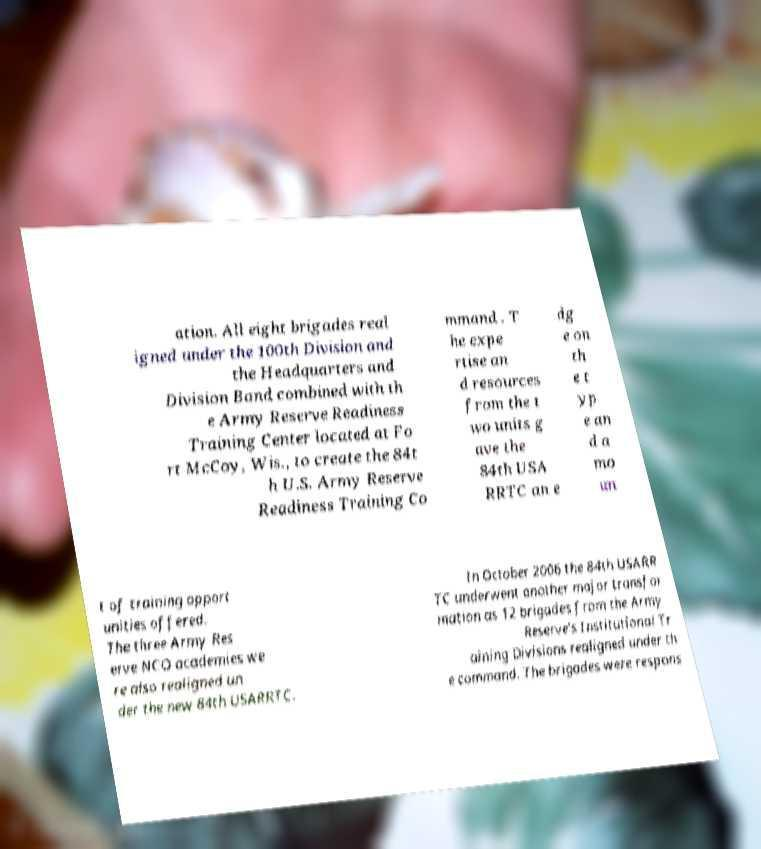Can you read and provide the text displayed in the image?This photo seems to have some interesting text. Can you extract and type it out for me? ation. All eight brigades real igned under the 100th Division and the Headquarters and Division Band combined with th e Army Reserve Readiness Training Center located at Fo rt McCoy, Wis., to create the 84t h U.S. Army Reserve Readiness Training Co mmand . T he expe rtise an d resources from the t wo units g ave the 84th USA RRTC an e dg e on th e t yp e an d a mo un t of training opport unities offered. The three Army Res erve NCO academies we re also realigned un der the new 84th USARRTC. In October 2006 the 84th USARR TC underwent another major transfor mation as 12 brigades from the Army Reserve's Institutional Tr aining Divisions realigned under th e command. The brigades were respons 